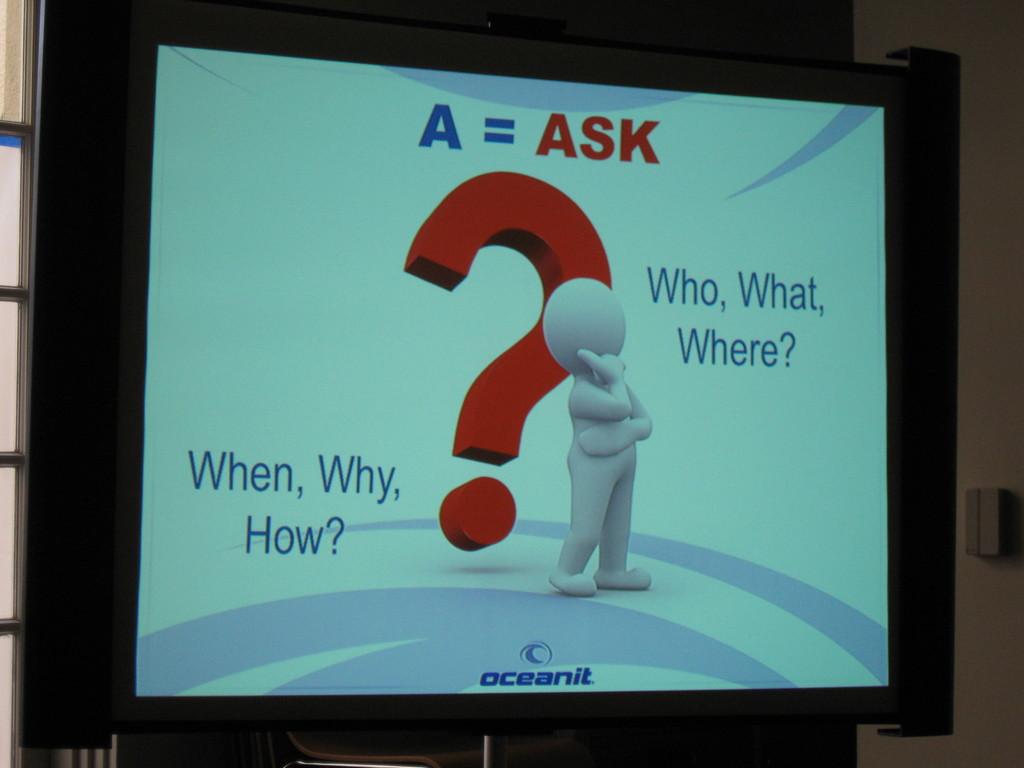What does a equal?
Your answer should be very brief. Ask. What company is this from?
Give a very brief answer. Oceanit. 